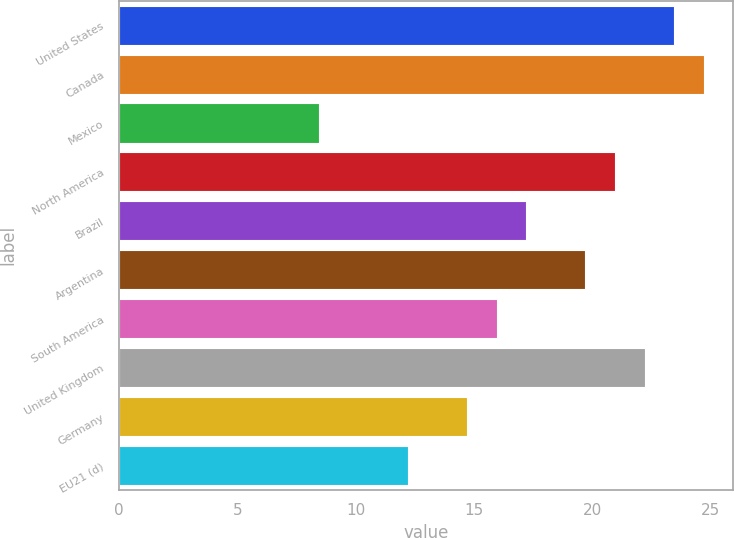Convert chart to OTSL. <chart><loc_0><loc_0><loc_500><loc_500><bar_chart><fcel>United States<fcel>Canada<fcel>Mexico<fcel>North America<fcel>Brazil<fcel>Argentina<fcel>South America<fcel>United Kingdom<fcel>Germany<fcel>EU21 (d)<nl><fcel>23.45<fcel>24.7<fcel>8.45<fcel>20.95<fcel>17.2<fcel>19.7<fcel>15.95<fcel>22.2<fcel>14.7<fcel>12.2<nl></chart> 